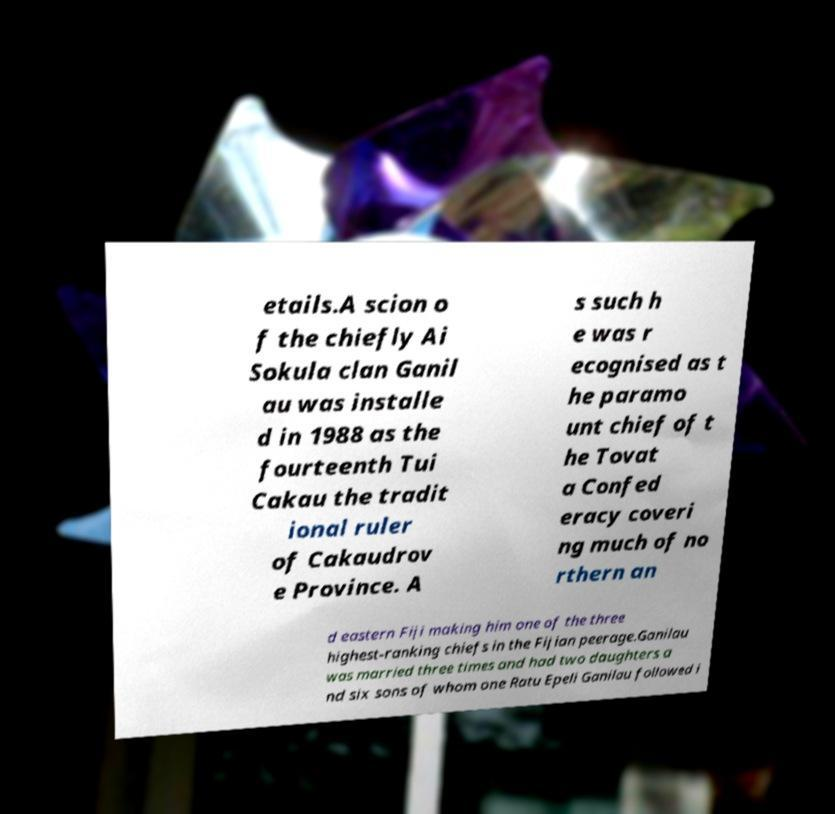I need the written content from this picture converted into text. Can you do that? etails.A scion o f the chiefly Ai Sokula clan Ganil au was installe d in 1988 as the fourteenth Tui Cakau the tradit ional ruler of Cakaudrov e Province. A s such h e was r ecognised as t he paramo unt chief of t he Tovat a Confed eracy coveri ng much of no rthern an d eastern Fiji making him one of the three highest-ranking chiefs in the Fijian peerage.Ganilau was married three times and had two daughters a nd six sons of whom one Ratu Epeli Ganilau followed i 